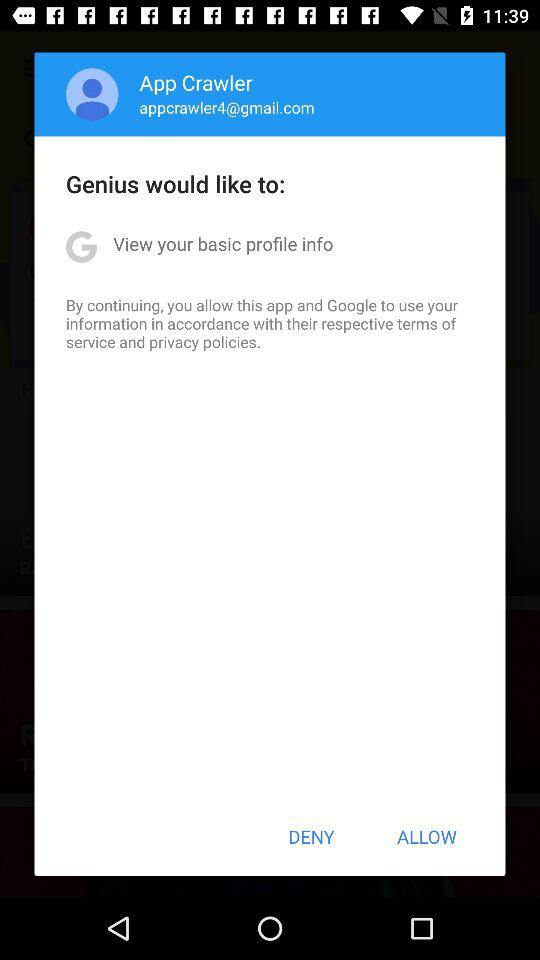What is the name of the user? The name of the user is App Crawler. 